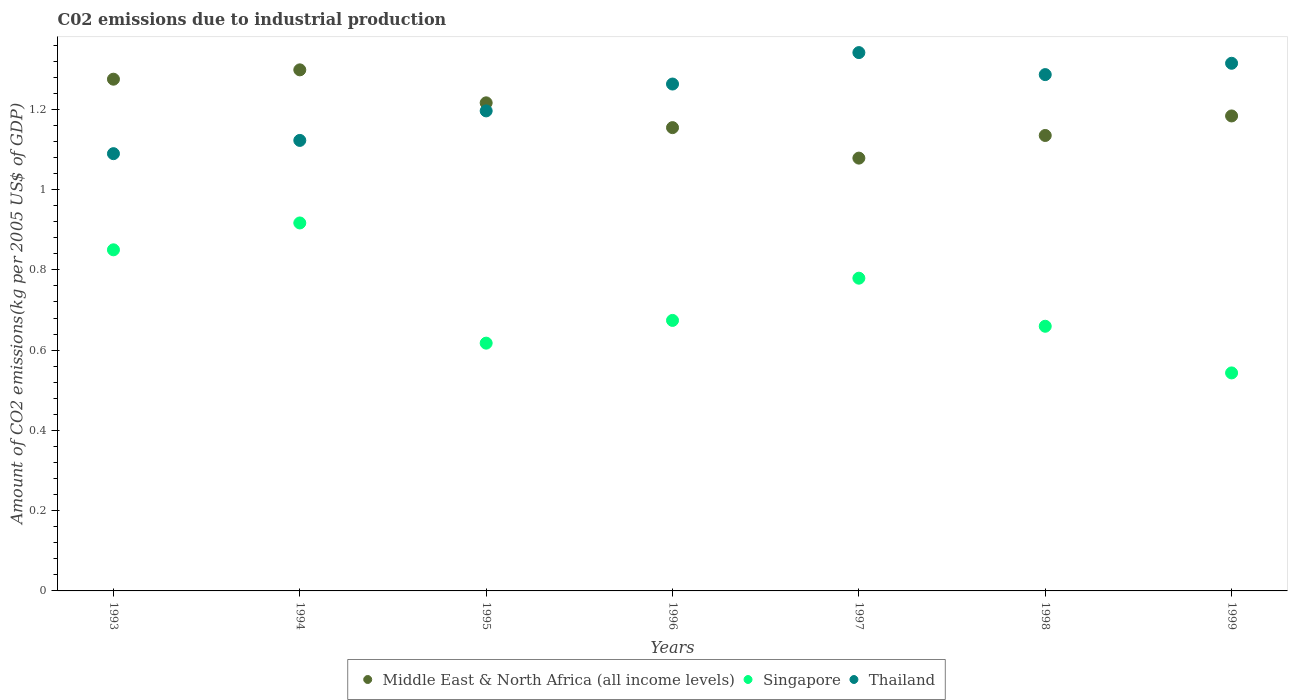Is the number of dotlines equal to the number of legend labels?
Offer a very short reply. Yes. What is the amount of CO2 emitted due to industrial production in Thailand in 1995?
Offer a very short reply. 1.2. Across all years, what is the maximum amount of CO2 emitted due to industrial production in Thailand?
Offer a very short reply. 1.34. Across all years, what is the minimum amount of CO2 emitted due to industrial production in Thailand?
Offer a very short reply. 1.09. What is the total amount of CO2 emitted due to industrial production in Middle East & North Africa (all income levels) in the graph?
Provide a succinct answer. 8.34. What is the difference between the amount of CO2 emitted due to industrial production in Thailand in 1993 and that in 1999?
Ensure brevity in your answer.  -0.23. What is the difference between the amount of CO2 emitted due to industrial production in Thailand in 1994 and the amount of CO2 emitted due to industrial production in Singapore in 1996?
Your answer should be very brief. 0.45. What is the average amount of CO2 emitted due to industrial production in Thailand per year?
Your answer should be very brief. 1.23. In the year 1994, what is the difference between the amount of CO2 emitted due to industrial production in Singapore and amount of CO2 emitted due to industrial production in Thailand?
Your answer should be very brief. -0.21. In how many years, is the amount of CO2 emitted due to industrial production in Middle East & North Africa (all income levels) greater than 0.6000000000000001 kg?
Keep it short and to the point. 7. What is the ratio of the amount of CO2 emitted due to industrial production in Thailand in 1993 to that in 1997?
Ensure brevity in your answer.  0.81. Is the amount of CO2 emitted due to industrial production in Singapore in 1997 less than that in 1999?
Provide a succinct answer. No. What is the difference between the highest and the second highest amount of CO2 emitted due to industrial production in Middle East & North Africa (all income levels)?
Ensure brevity in your answer.  0.02. What is the difference between the highest and the lowest amount of CO2 emitted due to industrial production in Thailand?
Ensure brevity in your answer.  0.25. Does the amount of CO2 emitted due to industrial production in Singapore monotonically increase over the years?
Your response must be concise. No. How many dotlines are there?
Give a very brief answer. 3. What is the difference between two consecutive major ticks on the Y-axis?
Your answer should be very brief. 0.2. Are the values on the major ticks of Y-axis written in scientific E-notation?
Your answer should be very brief. No. Does the graph contain grids?
Offer a terse response. No. Where does the legend appear in the graph?
Give a very brief answer. Bottom center. How many legend labels are there?
Offer a terse response. 3. What is the title of the graph?
Offer a very short reply. C02 emissions due to industrial production. What is the label or title of the Y-axis?
Give a very brief answer. Amount of CO2 emissions(kg per 2005 US$ of GDP). What is the Amount of CO2 emissions(kg per 2005 US$ of GDP) of Middle East & North Africa (all income levels) in 1993?
Make the answer very short. 1.28. What is the Amount of CO2 emissions(kg per 2005 US$ of GDP) of Singapore in 1993?
Offer a very short reply. 0.85. What is the Amount of CO2 emissions(kg per 2005 US$ of GDP) of Thailand in 1993?
Keep it short and to the point. 1.09. What is the Amount of CO2 emissions(kg per 2005 US$ of GDP) of Middle East & North Africa (all income levels) in 1994?
Your answer should be compact. 1.3. What is the Amount of CO2 emissions(kg per 2005 US$ of GDP) of Singapore in 1994?
Give a very brief answer. 0.92. What is the Amount of CO2 emissions(kg per 2005 US$ of GDP) of Thailand in 1994?
Ensure brevity in your answer.  1.12. What is the Amount of CO2 emissions(kg per 2005 US$ of GDP) in Middle East & North Africa (all income levels) in 1995?
Your answer should be very brief. 1.22. What is the Amount of CO2 emissions(kg per 2005 US$ of GDP) of Singapore in 1995?
Offer a terse response. 0.62. What is the Amount of CO2 emissions(kg per 2005 US$ of GDP) of Thailand in 1995?
Your answer should be compact. 1.2. What is the Amount of CO2 emissions(kg per 2005 US$ of GDP) in Middle East & North Africa (all income levels) in 1996?
Ensure brevity in your answer.  1.15. What is the Amount of CO2 emissions(kg per 2005 US$ of GDP) in Singapore in 1996?
Offer a terse response. 0.67. What is the Amount of CO2 emissions(kg per 2005 US$ of GDP) in Thailand in 1996?
Keep it short and to the point. 1.26. What is the Amount of CO2 emissions(kg per 2005 US$ of GDP) of Middle East & North Africa (all income levels) in 1997?
Offer a terse response. 1.08. What is the Amount of CO2 emissions(kg per 2005 US$ of GDP) of Singapore in 1997?
Provide a short and direct response. 0.78. What is the Amount of CO2 emissions(kg per 2005 US$ of GDP) of Thailand in 1997?
Keep it short and to the point. 1.34. What is the Amount of CO2 emissions(kg per 2005 US$ of GDP) of Middle East & North Africa (all income levels) in 1998?
Offer a very short reply. 1.13. What is the Amount of CO2 emissions(kg per 2005 US$ of GDP) of Singapore in 1998?
Ensure brevity in your answer.  0.66. What is the Amount of CO2 emissions(kg per 2005 US$ of GDP) of Thailand in 1998?
Your response must be concise. 1.29. What is the Amount of CO2 emissions(kg per 2005 US$ of GDP) in Middle East & North Africa (all income levels) in 1999?
Your response must be concise. 1.18. What is the Amount of CO2 emissions(kg per 2005 US$ of GDP) of Singapore in 1999?
Ensure brevity in your answer.  0.54. What is the Amount of CO2 emissions(kg per 2005 US$ of GDP) of Thailand in 1999?
Keep it short and to the point. 1.31. Across all years, what is the maximum Amount of CO2 emissions(kg per 2005 US$ of GDP) of Middle East & North Africa (all income levels)?
Make the answer very short. 1.3. Across all years, what is the maximum Amount of CO2 emissions(kg per 2005 US$ of GDP) in Singapore?
Make the answer very short. 0.92. Across all years, what is the maximum Amount of CO2 emissions(kg per 2005 US$ of GDP) of Thailand?
Ensure brevity in your answer.  1.34. Across all years, what is the minimum Amount of CO2 emissions(kg per 2005 US$ of GDP) of Middle East & North Africa (all income levels)?
Offer a terse response. 1.08. Across all years, what is the minimum Amount of CO2 emissions(kg per 2005 US$ of GDP) in Singapore?
Offer a terse response. 0.54. Across all years, what is the minimum Amount of CO2 emissions(kg per 2005 US$ of GDP) in Thailand?
Provide a short and direct response. 1.09. What is the total Amount of CO2 emissions(kg per 2005 US$ of GDP) in Middle East & North Africa (all income levels) in the graph?
Your answer should be compact. 8.34. What is the total Amount of CO2 emissions(kg per 2005 US$ of GDP) in Singapore in the graph?
Your answer should be very brief. 5.04. What is the total Amount of CO2 emissions(kg per 2005 US$ of GDP) of Thailand in the graph?
Provide a succinct answer. 8.61. What is the difference between the Amount of CO2 emissions(kg per 2005 US$ of GDP) in Middle East & North Africa (all income levels) in 1993 and that in 1994?
Your response must be concise. -0.02. What is the difference between the Amount of CO2 emissions(kg per 2005 US$ of GDP) in Singapore in 1993 and that in 1994?
Provide a succinct answer. -0.07. What is the difference between the Amount of CO2 emissions(kg per 2005 US$ of GDP) of Thailand in 1993 and that in 1994?
Your response must be concise. -0.03. What is the difference between the Amount of CO2 emissions(kg per 2005 US$ of GDP) in Middle East & North Africa (all income levels) in 1993 and that in 1995?
Your answer should be compact. 0.06. What is the difference between the Amount of CO2 emissions(kg per 2005 US$ of GDP) of Singapore in 1993 and that in 1995?
Provide a succinct answer. 0.23. What is the difference between the Amount of CO2 emissions(kg per 2005 US$ of GDP) in Thailand in 1993 and that in 1995?
Make the answer very short. -0.11. What is the difference between the Amount of CO2 emissions(kg per 2005 US$ of GDP) of Middle East & North Africa (all income levels) in 1993 and that in 1996?
Provide a short and direct response. 0.12. What is the difference between the Amount of CO2 emissions(kg per 2005 US$ of GDP) in Singapore in 1993 and that in 1996?
Keep it short and to the point. 0.18. What is the difference between the Amount of CO2 emissions(kg per 2005 US$ of GDP) in Thailand in 1993 and that in 1996?
Make the answer very short. -0.17. What is the difference between the Amount of CO2 emissions(kg per 2005 US$ of GDP) in Middle East & North Africa (all income levels) in 1993 and that in 1997?
Provide a succinct answer. 0.2. What is the difference between the Amount of CO2 emissions(kg per 2005 US$ of GDP) of Singapore in 1993 and that in 1997?
Make the answer very short. 0.07. What is the difference between the Amount of CO2 emissions(kg per 2005 US$ of GDP) of Thailand in 1993 and that in 1997?
Offer a very short reply. -0.25. What is the difference between the Amount of CO2 emissions(kg per 2005 US$ of GDP) in Middle East & North Africa (all income levels) in 1993 and that in 1998?
Provide a short and direct response. 0.14. What is the difference between the Amount of CO2 emissions(kg per 2005 US$ of GDP) of Singapore in 1993 and that in 1998?
Keep it short and to the point. 0.19. What is the difference between the Amount of CO2 emissions(kg per 2005 US$ of GDP) of Thailand in 1993 and that in 1998?
Give a very brief answer. -0.2. What is the difference between the Amount of CO2 emissions(kg per 2005 US$ of GDP) of Middle East & North Africa (all income levels) in 1993 and that in 1999?
Offer a very short reply. 0.09. What is the difference between the Amount of CO2 emissions(kg per 2005 US$ of GDP) in Singapore in 1993 and that in 1999?
Provide a succinct answer. 0.31. What is the difference between the Amount of CO2 emissions(kg per 2005 US$ of GDP) in Thailand in 1993 and that in 1999?
Your response must be concise. -0.23. What is the difference between the Amount of CO2 emissions(kg per 2005 US$ of GDP) in Middle East & North Africa (all income levels) in 1994 and that in 1995?
Your response must be concise. 0.08. What is the difference between the Amount of CO2 emissions(kg per 2005 US$ of GDP) of Singapore in 1994 and that in 1995?
Offer a terse response. 0.3. What is the difference between the Amount of CO2 emissions(kg per 2005 US$ of GDP) in Thailand in 1994 and that in 1995?
Keep it short and to the point. -0.07. What is the difference between the Amount of CO2 emissions(kg per 2005 US$ of GDP) in Middle East & North Africa (all income levels) in 1994 and that in 1996?
Make the answer very short. 0.14. What is the difference between the Amount of CO2 emissions(kg per 2005 US$ of GDP) of Singapore in 1994 and that in 1996?
Your answer should be very brief. 0.24. What is the difference between the Amount of CO2 emissions(kg per 2005 US$ of GDP) of Thailand in 1994 and that in 1996?
Provide a succinct answer. -0.14. What is the difference between the Amount of CO2 emissions(kg per 2005 US$ of GDP) in Middle East & North Africa (all income levels) in 1994 and that in 1997?
Your answer should be compact. 0.22. What is the difference between the Amount of CO2 emissions(kg per 2005 US$ of GDP) in Singapore in 1994 and that in 1997?
Keep it short and to the point. 0.14. What is the difference between the Amount of CO2 emissions(kg per 2005 US$ of GDP) of Thailand in 1994 and that in 1997?
Your answer should be very brief. -0.22. What is the difference between the Amount of CO2 emissions(kg per 2005 US$ of GDP) of Middle East & North Africa (all income levels) in 1994 and that in 1998?
Give a very brief answer. 0.16. What is the difference between the Amount of CO2 emissions(kg per 2005 US$ of GDP) in Singapore in 1994 and that in 1998?
Provide a succinct answer. 0.26. What is the difference between the Amount of CO2 emissions(kg per 2005 US$ of GDP) in Thailand in 1994 and that in 1998?
Give a very brief answer. -0.16. What is the difference between the Amount of CO2 emissions(kg per 2005 US$ of GDP) in Middle East & North Africa (all income levels) in 1994 and that in 1999?
Give a very brief answer. 0.11. What is the difference between the Amount of CO2 emissions(kg per 2005 US$ of GDP) of Singapore in 1994 and that in 1999?
Give a very brief answer. 0.37. What is the difference between the Amount of CO2 emissions(kg per 2005 US$ of GDP) of Thailand in 1994 and that in 1999?
Make the answer very short. -0.19. What is the difference between the Amount of CO2 emissions(kg per 2005 US$ of GDP) in Middle East & North Africa (all income levels) in 1995 and that in 1996?
Provide a succinct answer. 0.06. What is the difference between the Amount of CO2 emissions(kg per 2005 US$ of GDP) of Singapore in 1995 and that in 1996?
Give a very brief answer. -0.06. What is the difference between the Amount of CO2 emissions(kg per 2005 US$ of GDP) in Thailand in 1995 and that in 1996?
Keep it short and to the point. -0.07. What is the difference between the Amount of CO2 emissions(kg per 2005 US$ of GDP) of Middle East & North Africa (all income levels) in 1995 and that in 1997?
Offer a terse response. 0.14. What is the difference between the Amount of CO2 emissions(kg per 2005 US$ of GDP) in Singapore in 1995 and that in 1997?
Provide a short and direct response. -0.16. What is the difference between the Amount of CO2 emissions(kg per 2005 US$ of GDP) of Thailand in 1995 and that in 1997?
Offer a very short reply. -0.15. What is the difference between the Amount of CO2 emissions(kg per 2005 US$ of GDP) of Middle East & North Africa (all income levels) in 1995 and that in 1998?
Provide a short and direct response. 0.08. What is the difference between the Amount of CO2 emissions(kg per 2005 US$ of GDP) in Singapore in 1995 and that in 1998?
Your answer should be compact. -0.04. What is the difference between the Amount of CO2 emissions(kg per 2005 US$ of GDP) of Thailand in 1995 and that in 1998?
Your response must be concise. -0.09. What is the difference between the Amount of CO2 emissions(kg per 2005 US$ of GDP) in Middle East & North Africa (all income levels) in 1995 and that in 1999?
Your answer should be very brief. 0.03. What is the difference between the Amount of CO2 emissions(kg per 2005 US$ of GDP) in Singapore in 1995 and that in 1999?
Provide a succinct answer. 0.07. What is the difference between the Amount of CO2 emissions(kg per 2005 US$ of GDP) in Thailand in 1995 and that in 1999?
Provide a short and direct response. -0.12. What is the difference between the Amount of CO2 emissions(kg per 2005 US$ of GDP) in Middle East & North Africa (all income levels) in 1996 and that in 1997?
Provide a short and direct response. 0.08. What is the difference between the Amount of CO2 emissions(kg per 2005 US$ of GDP) of Singapore in 1996 and that in 1997?
Ensure brevity in your answer.  -0.11. What is the difference between the Amount of CO2 emissions(kg per 2005 US$ of GDP) in Thailand in 1996 and that in 1997?
Ensure brevity in your answer.  -0.08. What is the difference between the Amount of CO2 emissions(kg per 2005 US$ of GDP) of Middle East & North Africa (all income levels) in 1996 and that in 1998?
Provide a succinct answer. 0.02. What is the difference between the Amount of CO2 emissions(kg per 2005 US$ of GDP) in Singapore in 1996 and that in 1998?
Your response must be concise. 0.01. What is the difference between the Amount of CO2 emissions(kg per 2005 US$ of GDP) in Thailand in 1996 and that in 1998?
Ensure brevity in your answer.  -0.02. What is the difference between the Amount of CO2 emissions(kg per 2005 US$ of GDP) in Middle East & North Africa (all income levels) in 1996 and that in 1999?
Provide a short and direct response. -0.03. What is the difference between the Amount of CO2 emissions(kg per 2005 US$ of GDP) in Singapore in 1996 and that in 1999?
Provide a succinct answer. 0.13. What is the difference between the Amount of CO2 emissions(kg per 2005 US$ of GDP) of Thailand in 1996 and that in 1999?
Offer a very short reply. -0.05. What is the difference between the Amount of CO2 emissions(kg per 2005 US$ of GDP) of Middle East & North Africa (all income levels) in 1997 and that in 1998?
Provide a short and direct response. -0.06. What is the difference between the Amount of CO2 emissions(kg per 2005 US$ of GDP) in Singapore in 1997 and that in 1998?
Your answer should be compact. 0.12. What is the difference between the Amount of CO2 emissions(kg per 2005 US$ of GDP) in Thailand in 1997 and that in 1998?
Provide a succinct answer. 0.05. What is the difference between the Amount of CO2 emissions(kg per 2005 US$ of GDP) in Middle East & North Africa (all income levels) in 1997 and that in 1999?
Your answer should be very brief. -0.11. What is the difference between the Amount of CO2 emissions(kg per 2005 US$ of GDP) of Singapore in 1997 and that in 1999?
Make the answer very short. 0.24. What is the difference between the Amount of CO2 emissions(kg per 2005 US$ of GDP) of Thailand in 1997 and that in 1999?
Give a very brief answer. 0.03. What is the difference between the Amount of CO2 emissions(kg per 2005 US$ of GDP) in Middle East & North Africa (all income levels) in 1998 and that in 1999?
Keep it short and to the point. -0.05. What is the difference between the Amount of CO2 emissions(kg per 2005 US$ of GDP) of Singapore in 1998 and that in 1999?
Make the answer very short. 0.12. What is the difference between the Amount of CO2 emissions(kg per 2005 US$ of GDP) of Thailand in 1998 and that in 1999?
Your answer should be very brief. -0.03. What is the difference between the Amount of CO2 emissions(kg per 2005 US$ of GDP) of Middle East & North Africa (all income levels) in 1993 and the Amount of CO2 emissions(kg per 2005 US$ of GDP) of Singapore in 1994?
Ensure brevity in your answer.  0.36. What is the difference between the Amount of CO2 emissions(kg per 2005 US$ of GDP) of Middle East & North Africa (all income levels) in 1993 and the Amount of CO2 emissions(kg per 2005 US$ of GDP) of Thailand in 1994?
Make the answer very short. 0.15. What is the difference between the Amount of CO2 emissions(kg per 2005 US$ of GDP) in Singapore in 1993 and the Amount of CO2 emissions(kg per 2005 US$ of GDP) in Thailand in 1994?
Your answer should be compact. -0.27. What is the difference between the Amount of CO2 emissions(kg per 2005 US$ of GDP) of Middle East & North Africa (all income levels) in 1993 and the Amount of CO2 emissions(kg per 2005 US$ of GDP) of Singapore in 1995?
Your answer should be very brief. 0.66. What is the difference between the Amount of CO2 emissions(kg per 2005 US$ of GDP) in Middle East & North Africa (all income levels) in 1993 and the Amount of CO2 emissions(kg per 2005 US$ of GDP) in Thailand in 1995?
Keep it short and to the point. 0.08. What is the difference between the Amount of CO2 emissions(kg per 2005 US$ of GDP) of Singapore in 1993 and the Amount of CO2 emissions(kg per 2005 US$ of GDP) of Thailand in 1995?
Make the answer very short. -0.35. What is the difference between the Amount of CO2 emissions(kg per 2005 US$ of GDP) in Middle East & North Africa (all income levels) in 1993 and the Amount of CO2 emissions(kg per 2005 US$ of GDP) in Singapore in 1996?
Offer a terse response. 0.6. What is the difference between the Amount of CO2 emissions(kg per 2005 US$ of GDP) in Middle East & North Africa (all income levels) in 1993 and the Amount of CO2 emissions(kg per 2005 US$ of GDP) in Thailand in 1996?
Offer a very short reply. 0.01. What is the difference between the Amount of CO2 emissions(kg per 2005 US$ of GDP) of Singapore in 1993 and the Amount of CO2 emissions(kg per 2005 US$ of GDP) of Thailand in 1996?
Your response must be concise. -0.41. What is the difference between the Amount of CO2 emissions(kg per 2005 US$ of GDP) of Middle East & North Africa (all income levels) in 1993 and the Amount of CO2 emissions(kg per 2005 US$ of GDP) of Singapore in 1997?
Give a very brief answer. 0.5. What is the difference between the Amount of CO2 emissions(kg per 2005 US$ of GDP) of Middle East & North Africa (all income levels) in 1993 and the Amount of CO2 emissions(kg per 2005 US$ of GDP) of Thailand in 1997?
Make the answer very short. -0.07. What is the difference between the Amount of CO2 emissions(kg per 2005 US$ of GDP) in Singapore in 1993 and the Amount of CO2 emissions(kg per 2005 US$ of GDP) in Thailand in 1997?
Offer a terse response. -0.49. What is the difference between the Amount of CO2 emissions(kg per 2005 US$ of GDP) in Middle East & North Africa (all income levels) in 1993 and the Amount of CO2 emissions(kg per 2005 US$ of GDP) in Singapore in 1998?
Your answer should be compact. 0.62. What is the difference between the Amount of CO2 emissions(kg per 2005 US$ of GDP) in Middle East & North Africa (all income levels) in 1993 and the Amount of CO2 emissions(kg per 2005 US$ of GDP) in Thailand in 1998?
Provide a succinct answer. -0.01. What is the difference between the Amount of CO2 emissions(kg per 2005 US$ of GDP) of Singapore in 1993 and the Amount of CO2 emissions(kg per 2005 US$ of GDP) of Thailand in 1998?
Your answer should be very brief. -0.44. What is the difference between the Amount of CO2 emissions(kg per 2005 US$ of GDP) of Middle East & North Africa (all income levels) in 1993 and the Amount of CO2 emissions(kg per 2005 US$ of GDP) of Singapore in 1999?
Keep it short and to the point. 0.73. What is the difference between the Amount of CO2 emissions(kg per 2005 US$ of GDP) of Middle East & North Africa (all income levels) in 1993 and the Amount of CO2 emissions(kg per 2005 US$ of GDP) of Thailand in 1999?
Provide a succinct answer. -0.04. What is the difference between the Amount of CO2 emissions(kg per 2005 US$ of GDP) of Singapore in 1993 and the Amount of CO2 emissions(kg per 2005 US$ of GDP) of Thailand in 1999?
Make the answer very short. -0.46. What is the difference between the Amount of CO2 emissions(kg per 2005 US$ of GDP) in Middle East & North Africa (all income levels) in 1994 and the Amount of CO2 emissions(kg per 2005 US$ of GDP) in Singapore in 1995?
Ensure brevity in your answer.  0.68. What is the difference between the Amount of CO2 emissions(kg per 2005 US$ of GDP) in Middle East & North Africa (all income levels) in 1994 and the Amount of CO2 emissions(kg per 2005 US$ of GDP) in Thailand in 1995?
Offer a very short reply. 0.1. What is the difference between the Amount of CO2 emissions(kg per 2005 US$ of GDP) of Singapore in 1994 and the Amount of CO2 emissions(kg per 2005 US$ of GDP) of Thailand in 1995?
Provide a succinct answer. -0.28. What is the difference between the Amount of CO2 emissions(kg per 2005 US$ of GDP) in Middle East & North Africa (all income levels) in 1994 and the Amount of CO2 emissions(kg per 2005 US$ of GDP) in Singapore in 1996?
Provide a succinct answer. 0.62. What is the difference between the Amount of CO2 emissions(kg per 2005 US$ of GDP) in Middle East & North Africa (all income levels) in 1994 and the Amount of CO2 emissions(kg per 2005 US$ of GDP) in Thailand in 1996?
Provide a succinct answer. 0.04. What is the difference between the Amount of CO2 emissions(kg per 2005 US$ of GDP) of Singapore in 1994 and the Amount of CO2 emissions(kg per 2005 US$ of GDP) of Thailand in 1996?
Ensure brevity in your answer.  -0.35. What is the difference between the Amount of CO2 emissions(kg per 2005 US$ of GDP) of Middle East & North Africa (all income levels) in 1994 and the Amount of CO2 emissions(kg per 2005 US$ of GDP) of Singapore in 1997?
Offer a very short reply. 0.52. What is the difference between the Amount of CO2 emissions(kg per 2005 US$ of GDP) in Middle East & North Africa (all income levels) in 1994 and the Amount of CO2 emissions(kg per 2005 US$ of GDP) in Thailand in 1997?
Ensure brevity in your answer.  -0.04. What is the difference between the Amount of CO2 emissions(kg per 2005 US$ of GDP) in Singapore in 1994 and the Amount of CO2 emissions(kg per 2005 US$ of GDP) in Thailand in 1997?
Your answer should be compact. -0.42. What is the difference between the Amount of CO2 emissions(kg per 2005 US$ of GDP) in Middle East & North Africa (all income levels) in 1994 and the Amount of CO2 emissions(kg per 2005 US$ of GDP) in Singapore in 1998?
Your response must be concise. 0.64. What is the difference between the Amount of CO2 emissions(kg per 2005 US$ of GDP) in Middle East & North Africa (all income levels) in 1994 and the Amount of CO2 emissions(kg per 2005 US$ of GDP) in Thailand in 1998?
Keep it short and to the point. 0.01. What is the difference between the Amount of CO2 emissions(kg per 2005 US$ of GDP) in Singapore in 1994 and the Amount of CO2 emissions(kg per 2005 US$ of GDP) in Thailand in 1998?
Keep it short and to the point. -0.37. What is the difference between the Amount of CO2 emissions(kg per 2005 US$ of GDP) of Middle East & North Africa (all income levels) in 1994 and the Amount of CO2 emissions(kg per 2005 US$ of GDP) of Singapore in 1999?
Offer a terse response. 0.76. What is the difference between the Amount of CO2 emissions(kg per 2005 US$ of GDP) of Middle East & North Africa (all income levels) in 1994 and the Amount of CO2 emissions(kg per 2005 US$ of GDP) of Thailand in 1999?
Ensure brevity in your answer.  -0.02. What is the difference between the Amount of CO2 emissions(kg per 2005 US$ of GDP) in Singapore in 1994 and the Amount of CO2 emissions(kg per 2005 US$ of GDP) in Thailand in 1999?
Your answer should be compact. -0.4. What is the difference between the Amount of CO2 emissions(kg per 2005 US$ of GDP) in Middle East & North Africa (all income levels) in 1995 and the Amount of CO2 emissions(kg per 2005 US$ of GDP) in Singapore in 1996?
Keep it short and to the point. 0.54. What is the difference between the Amount of CO2 emissions(kg per 2005 US$ of GDP) of Middle East & North Africa (all income levels) in 1995 and the Amount of CO2 emissions(kg per 2005 US$ of GDP) of Thailand in 1996?
Offer a very short reply. -0.05. What is the difference between the Amount of CO2 emissions(kg per 2005 US$ of GDP) of Singapore in 1995 and the Amount of CO2 emissions(kg per 2005 US$ of GDP) of Thailand in 1996?
Make the answer very short. -0.65. What is the difference between the Amount of CO2 emissions(kg per 2005 US$ of GDP) in Middle East & North Africa (all income levels) in 1995 and the Amount of CO2 emissions(kg per 2005 US$ of GDP) in Singapore in 1997?
Provide a short and direct response. 0.44. What is the difference between the Amount of CO2 emissions(kg per 2005 US$ of GDP) of Middle East & North Africa (all income levels) in 1995 and the Amount of CO2 emissions(kg per 2005 US$ of GDP) of Thailand in 1997?
Offer a terse response. -0.13. What is the difference between the Amount of CO2 emissions(kg per 2005 US$ of GDP) in Singapore in 1995 and the Amount of CO2 emissions(kg per 2005 US$ of GDP) in Thailand in 1997?
Your answer should be compact. -0.72. What is the difference between the Amount of CO2 emissions(kg per 2005 US$ of GDP) in Middle East & North Africa (all income levels) in 1995 and the Amount of CO2 emissions(kg per 2005 US$ of GDP) in Singapore in 1998?
Your response must be concise. 0.56. What is the difference between the Amount of CO2 emissions(kg per 2005 US$ of GDP) in Middle East & North Africa (all income levels) in 1995 and the Amount of CO2 emissions(kg per 2005 US$ of GDP) in Thailand in 1998?
Give a very brief answer. -0.07. What is the difference between the Amount of CO2 emissions(kg per 2005 US$ of GDP) in Singapore in 1995 and the Amount of CO2 emissions(kg per 2005 US$ of GDP) in Thailand in 1998?
Give a very brief answer. -0.67. What is the difference between the Amount of CO2 emissions(kg per 2005 US$ of GDP) of Middle East & North Africa (all income levels) in 1995 and the Amount of CO2 emissions(kg per 2005 US$ of GDP) of Singapore in 1999?
Make the answer very short. 0.67. What is the difference between the Amount of CO2 emissions(kg per 2005 US$ of GDP) in Middle East & North Africa (all income levels) in 1995 and the Amount of CO2 emissions(kg per 2005 US$ of GDP) in Thailand in 1999?
Offer a very short reply. -0.1. What is the difference between the Amount of CO2 emissions(kg per 2005 US$ of GDP) of Singapore in 1995 and the Amount of CO2 emissions(kg per 2005 US$ of GDP) of Thailand in 1999?
Provide a succinct answer. -0.7. What is the difference between the Amount of CO2 emissions(kg per 2005 US$ of GDP) of Middle East & North Africa (all income levels) in 1996 and the Amount of CO2 emissions(kg per 2005 US$ of GDP) of Singapore in 1997?
Provide a succinct answer. 0.38. What is the difference between the Amount of CO2 emissions(kg per 2005 US$ of GDP) in Middle East & North Africa (all income levels) in 1996 and the Amount of CO2 emissions(kg per 2005 US$ of GDP) in Thailand in 1997?
Provide a short and direct response. -0.19. What is the difference between the Amount of CO2 emissions(kg per 2005 US$ of GDP) of Singapore in 1996 and the Amount of CO2 emissions(kg per 2005 US$ of GDP) of Thailand in 1997?
Offer a terse response. -0.67. What is the difference between the Amount of CO2 emissions(kg per 2005 US$ of GDP) in Middle East & North Africa (all income levels) in 1996 and the Amount of CO2 emissions(kg per 2005 US$ of GDP) in Singapore in 1998?
Keep it short and to the point. 0.49. What is the difference between the Amount of CO2 emissions(kg per 2005 US$ of GDP) in Middle East & North Africa (all income levels) in 1996 and the Amount of CO2 emissions(kg per 2005 US$ of GDP) in Thailand in 1998?
Keep it short and to the point. -0.13. What is the difference between the Amount of CO2 emissions(kg per 2005 US$ of GDP) in Singapore in 1996 and the Amount of CO2 emissions(kg per 2005 US$ of GDP) in Thailand in 1998?
Give a very brief answer. -0.61. What is the difference between the Amount of CO2 emissions(kg per 2005 US$ of GDP) in Middle East & North Africa (all income levels) in 1996 and the Amount of CO2 emissions(kg per 2005 US$ of GDP) in Singapore in 1999?
Give a very brief answer. 0.61. What is the difference between the Amount of CO2 emissions(kg per 2005 US$ of GDP) of Middle East & North Africa (all income levels) in 1996 and the Amount of CO2 emissions(kg per 2005 US$ of GDP) of Thailand in 1999?
Keep it short and to the point. -0.16. What is the difference between the Amount of CO2 emissions(kg per 2005 US$ of GDP) of Singapore in 1996 and the Amount of CO2 emissions(kg per 2005 US$ of GDP) of Thailand in 1999?
Your answer should be compact. -0.64. What is the difference between the Amount of CO2 emissions(kg per 2005 US$ of GDP) in Middle East & North Africa (all income levels) in 1997 and the Amount of CO2 emissions(kg per 2005 US$ of GDP) in Singapore in 1998?
Offer a very short reply. 0.42. What is the difference between the Amount of CO2 emissions(kg per 2005 US$ of GDP) in Middle East & North Africa (all income levels) in 1997 and the Amount of CO2 emissions(kg per 2005 US$ of GDP) in Thailand in 1998?
Your answer should be compact. -0.21. What is the difference between the Amount of CO2 emissions(kg per 2005 US$ of GDP) of Singapore in 1997 and the Amount of CO2 emissions(kg per 2005 US$ of GDP) of Thailand in 1998?
Ensure brevity in your answer.  -0.51. What is the difference between the Amount of CO2 emissions(kg per 2005 US$ of GDP) of Middle East & North Africa (all income levels) in 1997 and the Amount of CO2 emissions(kg per 2005 US$ of GDP) of Singapore in 1999?
Offer a terse response. 0.54. What is the difference between the Amount of CO2 emissions(kg per 2005 US$ of GDP) of Middle East & North Africa (all income levels) in 1997 and the Amount of CO2 emissions(kg per 2005 US$ of GDP) of Thailand in 1999?
Provide a short and direct response. -0.24. What is the difference between the Amount of CO2 emissions(kg per 2005 US$ of GDP) in Singapore in 1997 and the Amount of CO2 emissions(kg per 2005 US$ of GDP) in Thailand in 1999?
Offer a very short reply. -0.54. What is the difference between the Amount of CO2 emissions(kg per 2005 US$ of GDP) of Middle East & North Africa (all income levels) in 1998 and the Amount of CO2 emissions(kg per 2005 US$ of GDP) of Singapore in 1999?
Your answer should be very brief. 0.59. What is the difference between the Amount of CO2 emissions(kg per 2005 US$ of GDP) in Middle East & North Africa (all income levels) in 1998 and the Amount of CO2 emissions(kg per 2005 US$ of GDP) in Thailand in 1999?
Your answer should be very brief. -0.18. What is the difference between the Amount of CO2 emissions(kg per 2005 US$ of GDP) in Singapore in 1998 and the Amount of CO2 emissions(kg per 2005 US$ of GDP) in Thailand in 1999?
Offer a very short reply. -0.66. What is the average Amount of CO2 emissions(kg per 2005 US$ of GDP) of Middle East & North Africa (all income levels) per year?
Keep it short and to the point. 1.19. What is the average Amount of CO2 emissions(kg per 2005 US$ of GDP) in Singapore per year?
Give a very brief answer. 0.72. What is the average Amount of CO2 emissions(kg per 2005 US$ of GDP) of Thailand per year?
Ensure brevity in your answer.  1.23. In the year 1993, what is the difference between the Amount of CO2 emissions(kg per 2005 US$ of GDP) in Middle East & North Africa (all income levels) and Amount of CO2 emissions(kg per 2005 US$ of GDP) in Singapore?
Make the answer very short. 0.43. In the year 1993, what is the difference between the Amount of CO2 emissions(kg per 2005 US$ of GDP) in Middle East & North Africa (all income levels) and Amount of CO2 emissions(kg per 2005 US$ of GDP) in Thailand?
Provide a short and direct response. 0.19. In the year 1993, what is the difference between the Amount of CO2 emissions(kg per 2005 US$ of GDP) in Singapore and Amount of CO2 emissions(kg per 2005 US$ of GDP) in Thailand?
Your response must be concise. -0.24. In the year 1994, what is the difference between the Amount of CO2 emissions(kg per 2005 US$ of GDP) in Middle East & North Africa (all income levels) and Amount of CO2 emissions(kg per 2005 US$ of GDP) in Singapore?
Your response must be concise. 0.38. In the year 1994, what is the difference between the Amount of CO2 emissions(kg per 2005 US$ of GDP) in Middle East & North Africa (all income levels) and Amount of CO2 emissions(kg per 2005 US$ of GDP) in Thailand?
Your response must be concise. 0.18. In the year 1994, what is the difference between the Amount of CO2 emissions(kg per 2005 US$ of GDP) in Singapore and Amount of CO2 emissions(kg per 2005 US$ of GDP) in Thailand?
Keep it short and to the point. -0.21. In the year 1995, what is the difference between the Amount of CO2 emissions(kg per 2005 US$ of GDP) of Middle East & North Africa (all income levels) and Amount of CO2 emissions(kg per 2005 US$ of GDP) of Singapore?
Your answer should be very brief. 0.6. In the year 1995, what is the difference between the Amount of CO2 emissions(kg per 2005 US$ of GDP) of Middle East & North Africa (all income levels) and Amount of CO2 emissions(kg per 2005 US$ of GDP) of Thailand?
Your answer should be compact. 0.02. In the year 1995, what is the difference between the Amount of CO2 emissions(kg per 2005 US$ of GDP) in Singapore and Amount of CO2 emissions(kg per 2005 US$ of GDP) in Thailand?
Provide a succinct answer. -0.58. In the year 1996, what is the difference between the Amount of CO2 emissions(kg per 2005 US$ of GDP) of Middle East & North Africa (all income levels) and Amount of CO2 emissions(kg per 2005 US$ of GDP) of Singapore?
Give a very brief answer. 0.48. In the year 1996, what is the difference between the Amount of CO2 emissions(kg per 2005 US$ of GDP) of Middle East & North Africa (all income levels) and Amount of CO2 emissions(kg per 2005 US$ of GDP) of Thailand?
Ensure brevity in your answer.  -0.11. In the year 1996, what is the difference between the Amount of CO2 emissions(kg per 2005 US$ of GDP) in Singapore and Amount of CO2 emissions(kg per 2005 US$ of GDP) in Thailand?
Your response must be concise. -0.59. In the year 1997, what is the difference between the Amount of CO2 emissions(kg per 2005 US$ of GDP) of Middle East & North Africa (all income levels) and Amount of CO2 emissions(kg per 2005 US$ of GDP) of Singapore?
Offer a terse response. 0.3. In the year 1997, what is the difference between the Amount of CO2 emissions(kg per 2005 US$ of GDP) of Middle East & North Africa (all income levels) and Amount of CO2 emissions(kg per 2005 US$ of GDP) of Thailand?
Your answer should be compact. -0.26. In the year 1997, what is the difference between the Amount of CO2 emissions(kg per 2005 US$ of GDP) in Singapore and Amount of CO2 emissions(kg per 2005 US$ of GDP) in Thailand?
Keep it short and to the point. -0.56. In the year 1998, what is the difference between the Amount of CO2 emissions(kg per 2005 US$ of GDP) of Middle East & North Africa (all income levels) and Amount of CO2 emissions(kg per 2005 US$ of GDP) of Singapore?
Offer a terse response. 0.48. In the year 1998, what is the difference between the Amount of CO2 emissions(kg per 2005 US$ of GDP) of Middle East & North Africa (all income levels) and Amount of CO2 emissions(kg per 2005 US$ of GDP) of Thailand?
Provide a short and direct response. -0.15. In the year 1998, what is the difference between the Amount of CO2 emissions(kg per 2005 US$ of GDP) of Singapore and Amount of CO2 emissions(kg per 2005 US$ of GDP) of Thailand?
Give a very brief answer. -0.63. In the year 1999, what is the difference between the Amount of CO2 emissions(kg per 2005 US$ of GDP) in Middle East & North Africa (all income levels) and Amount of CO2 emissions(kg per 2005 US$ of GDP) in Singapore?
Offer a terse response. 0.64. In the year 1999, what is the difference between the Amount of CO2 emissions(kg per 2005 US$ of GDP) in Middle East & North Africa (all income levels) and Amount of CO2 emissions(kg per 2005 US$ of GDP) in Thailand?
Provide a short and direct response. -0.13. In the year 1999, what is the difference between the Amount of CO2 emissions(kg per 2005 US$ of GDP) of Singapore and Amount of CO2 emissions(kg per 2005 US$ of GDP) of Thailand?
Make the answer very short. -0.77. What is the ratio of the Amount of CO2 emissions(kg per 2005 US$ of GDP) of Middle East & North Africa (all income levels) in 1993 to that in 1994?
Offer a terse response. 0.98. What is the ratio of the Amount of CO2 emissions(kg per 2005 US$ of GDP) of Singapore in 1993 to that in 1994?
Your answer should be very brief. 0.93. What is the ratio of the Amount of CO2 emissions(kg per 2005 US$ of GDP) in Thailand in 1993 to that in 1994?
Make the answer very short. 0.97. What is the ratio of the Amount of CO2 emissions(kg per 2005 US$ of GDP) of Middle East & North Africa (all income levels) in 1993 to that in 1995?
Offer a very short reply. 1.05. What is the ratio of the Amount of CO2 emissions(kg per 2005 US$ of GDP) in Singapore in 1993 to that in 1995?
Ensure brevity in your answer.  1.38. What is the ratio of the Amount of CO2 emissions(kg per 2005 US$ of GDP) of Thailand in 1993 to that in 1995?
Ensure brevity in your answer.  0.91. What is the ratio of the Amount of CO2 emissions(kg per 2005 US$ of GDP) in Middle East & North Africa (all income levels) in 1993 to that in 1996?
Offer a very short reply. 1.1. What is the ratio of the Amount of CO2 emissions(kg per 2005 US$ of GDP) in Singapore in 1993 to that in 1996?
Offer a terse response. 1.26. What is the ratio of the Amount of CO2 emissions(kg per 2005 US$ of GDP) in Thailand in 1993 to that in 1996?
Your answer should be compact. 0.86. What is the ratio of the Amount of CO2 emissions(kg per 2005 US$ of GDP) of Middle East & North Africa (all income levels) in 1993 to that in 1997?
Offer a terse response. 1.18. What is the ratio of the Amount of CO2 emissions(kg per 2005 US$ of GDP) in Singapore in 1993 to that in 1997?
Your answer should be compact. 1.09. What is the ratio of the Amount of CO2 emissions(kg per 2005 US$ of GDP) in Thailand in 1993 to that in 1997?
Provide a succinct answer. 0.81. What is the ratio of the Amount of CO2 emissions(kg per 2005 US$ of GDP) of Middle East & North Africa (all income levels) in 1993 to that in 1998?
Your answer should be very brief. 1.12. What is the ratio of the Amount of CO2 emissions(kg per 2005 US$ of GDP) of Singapore in 1993 to that in 1998?
Your answer should be very brief. 1.29. What is the ratio of the Amount of CO2 emissions(kg per 2005 US$ of GDP) of Thailand in 1993 to that in 1998?
Make the answer very short. 0.85. What is the ratio of the Amount of CO2 emissions(kg per 2005 US$ of GDP) in Middle East & North Africa (all income levels) in 1993 to that in 1999?
Your answer should be very brief. 1.08. What is the ratio of the Amount of CO2 emissions(kg per 2005 US$ of GDP) of Singapore in 1993 to that in 1999?
Keep it short and to the point. 1.56. What is the ratio of the Amount of CO2 emissions(kg per 2005 US$ of GDP) of Thailand in 1993 to that in 1999?
Your answer should be very brief. 0.83. What is the ratio of the Amount of CO2 emissions(kg per 2005 US$ of GDP) of Middle East & North Africa (all income levels) in 1994 to that in 1995?
Offer a very short reply. 1.07. What is the ratio of the Amount of CO2 emissions(kg per 2005 US$ of GDP) of Singapore in 1994 to that in 1995?
Your response must be concise. 1.49. What is the ratio of the Amount of CO2 emissions(kg per 2005 US$ of GDP) in Thailand in 1994 to that in 1995?
Ensure brevity in your answer.  0.94. What is the ratio of the Amount of CO2 emissions(kg per 2005 US$ of GDP) in Middle East & North Africa (all income levels) in 1994 to that in 1996?
Your answer should be very brief. 1.12. What is the ratio of the Amount of CO2 emissions(kg per 2005 US$ of GDP) of Singapore in 1994 to that in 1996?
Offer a terse response. 1.36. What is the ratio of the Amount of CO2 emissions(kg per 2005 US$ of GDP) of Thailand in 1994 to that in 1996?
Provide a short and direct response. 0.89. What is the ratio of the Amount of CO2 emissions(kg per 2005 US$ of GDP) of Middle East & North Africa (all income levels) in 1994 to that in 1997?
Offer a very short reply. 1.2. What is the ratio of the Amount of CO2 emissions(kg per 2005 US$ of GDP) of Singapore in 1994 to that in 1997?
Keep it short and to the point. 1.18. What is the ratio of the Amount of CO2 emissions(kg per 2005 US$ of GDP) in Thailand in 1994 to that in 1997?
Ensure brevity in your answer.  0.84. What is the ratio of the Amount of CO2 emissions(kg per 2005 US$ of GDP) of Middle East & North Africa (all income levels) in 1994 to that in 1998?
Give a very brief answer. 1.14. What is the ratio of the Amount of CO2 emissions(kg per 2005 US$ of GDP) of Singapore in 1994 to that in 1998?
Your answer should be very brief. 1.39. What is the ratio of the Amount of CO2 emissions(kg per 2005 US$ of GDP) in Thailand in 1994 to that in 1998?
Keep it short and to the point. 0.87. What is the ratio of the Amount of CO2 emissions(kg per 2005 US$ of GDP) in Middle East & North Africa (all income levels) in 1994 to that in 1999?
Make the answer very short. 1.1. What is the ratio of the Amount of CO2 emissions(kg per 2005 US$ of GDP) in Singapore in 1994 to that in 1999?
Ensure brevity in your answer.  1.69. What is the ratio of the Amount of CO2 emissions(kg per 2005 US$ of GDP) of Thailand in 1994 to that in 1999?
Your answer should be compact. 0.85. What is the ratio of the Amount of CO2 emissions(kg per 2005 US$ of GDP) in Middle East & North Africa (all income levels) in 1995 to that in 1996?
Offer a terse response. 1.05. What is the ratio of the Amount of CO2 emissions(kg per 2005 US$ of GDP) of Singapore in 1995 to that in 1996?
Your answer should be very brief. 0.92. What is the ratio of the Amount of CO2 emissions(kg per 2005 US$ of GDP) in Thailand in 1995 to that in 1996?
Give a very brief answer. 0.95. What is the ratio of the Amount of CO2 emissions(kg per 2005 US$ of GDP) of Middle East & North Africa (all income levels) in 1995 to that in 1997?
Your response must be concise. 1.13. What is the ratio of the Amount of CO2 emissions(kg per 2005 US$ of GDP) in Singapore in 1995 to that in 1997?
Provide a short and direct response. 0.79. What is the ratio of the Amount of CO2 emissions(kg per 2005 US$ of GDP) of Thailand in 1995 to that in 1997?
Make the answer very short. 0.89. What is the ratio of the Amount of CO2 emissions(kg per 2005 US$ of GDP) in Middle East & North Africa (all income levels) in 1995 to that in 1998?
Your answer should be very brief. 1.07. What is the ratio of the Amount of CO2 emissions(kg per 2005 US$ of GDP) in Singapore in 1995 to that in 1998?
Your response must be concise. 0.94. What is the ratio of the Amount of CO2 emissions(kg per 2005 US$ of GDP) in Thailand in 1995 to that in 1998?
Make the answer very short. 0.93. What is the ratio of the Amount of CO2 emissions(kg per 2005 US$ of GDP) in Middle East & North Africa (all income levels) in 1995 to that in 1999?
Ensure brevity in your answer.  1.03. What is the ratio of the Amount of CO2 emissions(kg per 2005 US$ of GDP) in Singapore in 1995 to that in 1999?
Your answer should be very brief. 1.14. What is the ratio of the Amount of CO2 emissions(kg per 2005 US$ of GDP) of Thailand in 1995 to that in 1999?
Make the answer very short. 0.91. What is the ratio of the Amount of CO2 emissions(kg per 2005 US$ of GDP) in Middle East & North Africa (all income levels) in 1996 to that in 1997?
Make the answer very short. 1.07. What is the ratio of the Amount of CO2 emissions(kg per 2005 US$ of GDP) in Singapore in 1996 to that in 1997?
Offer a terse response. 0.86. What is the ratio of the Amount of CO2 emissions(kg per 2005 US$ of GDP) of Thailand in 1996 to that in 1997?
Your answer should be compact. 0.94. What is the ratio of the Amount of CO2 emissions(kg per 2005 US$ of GDP) of Middle East & North Africa (all income levels) in 1996 to that in 1998?
Offer a very short reply. 1.02. What is the ratio of the Amount of CO2 emissions(kg per 2005 US$ of GDP) of Singapore in 1996 to that in 1998?
Offer a very short reply. 1.02. What is the ratio of the Amount of CO2 emissions(kg per 2005 US$ of GDP) in Thailand in 1996 to that in 1998?
Keep it short and to the point. 0.98. What is the ratio of the Amount of CO2 emissions(kg per 2005 US$ of GDP) of Middle East & North Africa (all income levels) in 1996 to that in 1999?
Provide a succinct answer. 0.98. What is the ratio of the Amount of CO2 emissions(kg per 2005 US$ of GDP) in Singapore in 1996 to that in 1999?
Provide a short and direct response. 1.24. What is the ratio of the Amount of CO2 emissions(kg per 2005 US$ of GDP) in Thailand in 1996 to that in 1999?
Keep it short and to the point. 0.96. What is the ratio of the Amount of CO2 emissions(kg per 2005 US$ of GDP) of Middle East & North Africa (all income levels) in 1997 to that in 1998?
Keep it short and to the point. 0.95. What is the ratio of the Amount of CO2 emissions(kg per 2005 US$ of GDP) of Singapore in 1997 to that in 1998?
Make the answer very short. 1.18. What is the ratio of the Amount of CO2 emissions(kg per 2005 US$ of GDP) in Thailand in 1997 to that in 1998?
Give a very brief answer. 1.04. What is the ratio of the Amount of CO2 emissions(kg per 2005 US$ of GDP) in Middle East & North Africa (all income levels) in 1997 to that in 1999?
Provide a succinct answer. 0.91. What is the ratio of the Amount of CO2 emissions(kg per 2005 US$ of GDP) in Singapore in 1997 to that in 1999?
Make the answer very short. 1.43. What is the ratio of the Amount of CO2 emissions(kg per 2005 US$ of GDP) in Thailand in 1997 to that in 1999?
Offer a terse response. 1.02. What is the ratio of the Amount of CO2 emissions(kg per 2005 US$ of GDP) in Middle East & North Africa (all income levels) in 1998 to that in 1999?
Make the answer very short. 0.96. What is the ratio of the Amount of CO2 emissions(kg per 2005 US$ of GDP) of Singapore in 1998 to that in 1999?
Offer a terse response. 1.21. What is the ratio of the Amount of CO2 emissions(kg per 2005 US$ of GDP) of Thailand in 1998 to that in 1999?
Offer a very short reply. 0.98. What is the difference between the highest and the second highest Amount of CO2 emissions(kg per 2005 US$ of GDP) of Middle East & North Africa (all income levels)?
Your response must be concise. 0.02. What is the difference between the highest and the second highest Amount of CO2 emissions(kg per 2005 US$ of GDP) in Singapore?
Your response must be concise. 0.07. What is the difference between the highest and the second highest Amount of CO2 emissions(kg per 2005 US$ of GDP) of Thailand?
Offer a very short reply. 0.03. What is the difference between the highest and the lowest Amount of CO2 emissions(kg per 2005 US$ of GDP) in Middle East & North Africa (all income levels)?
Your answer should be compact. 0.22. What is the difference between the highest and the lowest Amount of CO2 emissions(kg per 2005 US$ of GDP) in Singapore?
Give a very brief answer. 0.37. What is the difference between the highest and the lowest Amount of CO2 emissions(kg per 2005 US$ of GDP) of Thailand?
Your answer should be compact. 0.25. 